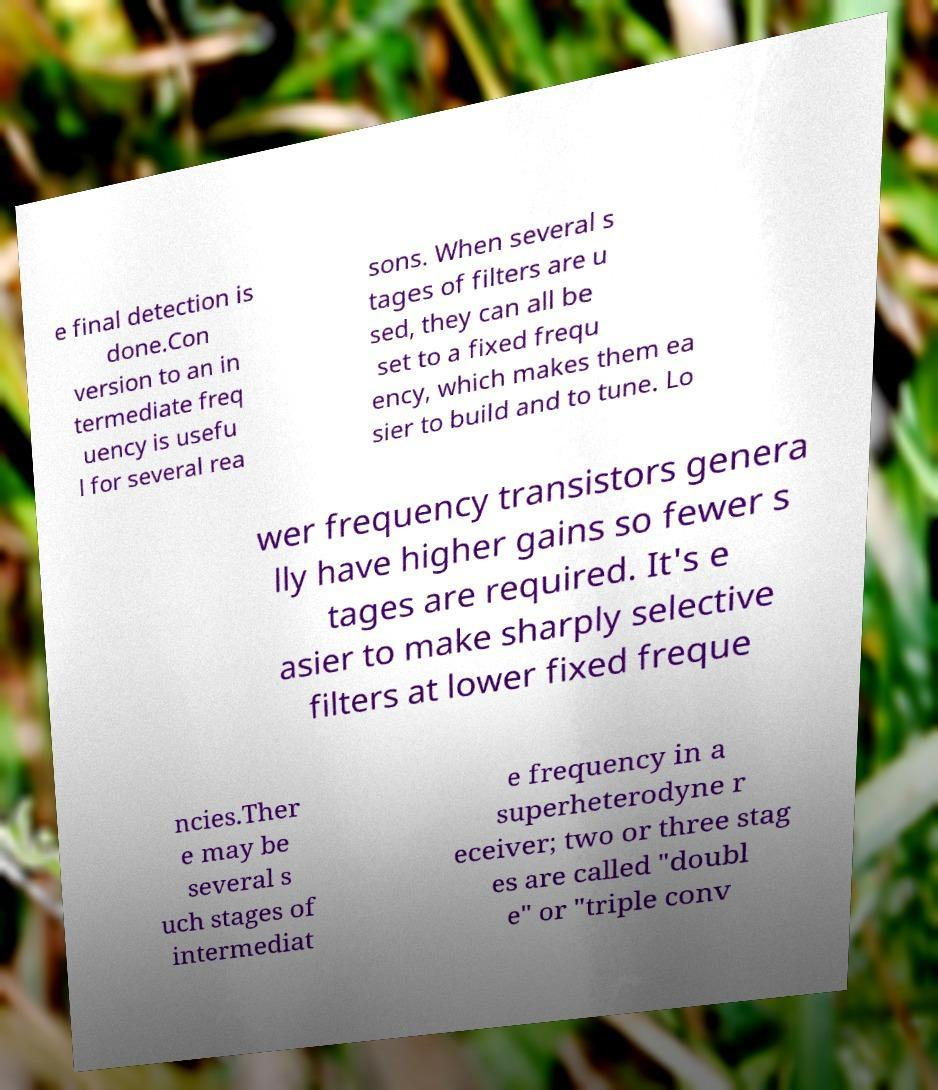Can you read and provide the text displayed in the image?This photo seems to have some interesting text. Can you extract and type it out for me? e final detection is done.Con version to an in termediate freq uency is usefu l for several rea sons. When several s tages of filters are u sed, they can all be set to a fixed frequ ency, which makes them ea sier to build and to tune. Lo wer frequency transistors genera lly have higher gains so fewer s tages are required. It's e asier to make sharply selective filters at lower fixed freque ncies.Ther e may be several s uch stages of intermediat e frequency in a superheterodyne r eceiver; two or three stag es are called "doubl e" or "triple conv 